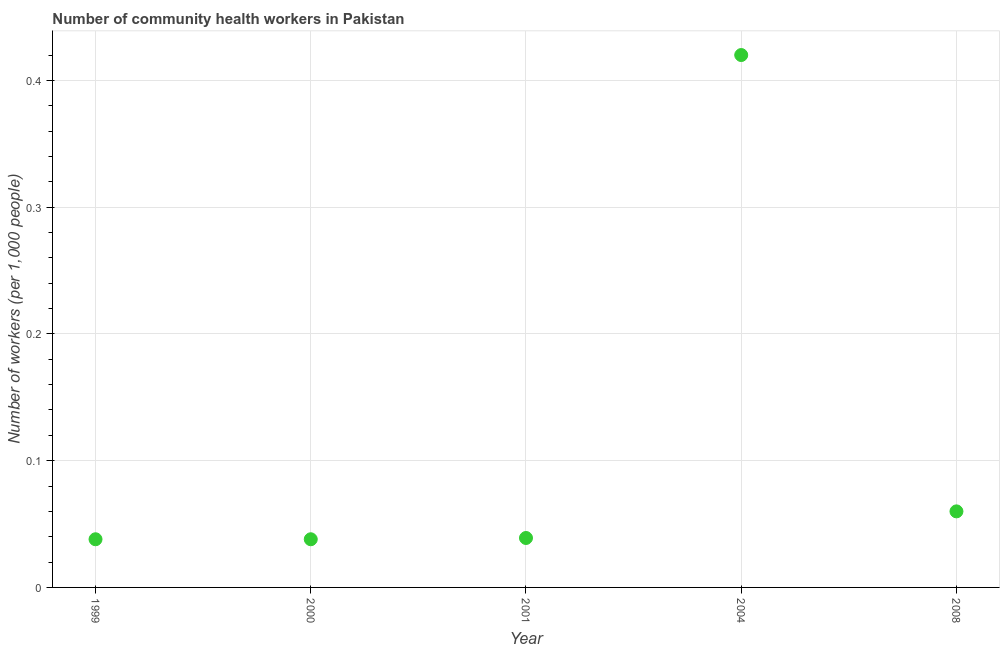What is the number of community health workers in 2004?
Offer a very short reply. 0.42. Across all years, what is the maximum number of community health workers?
Give a very brief answer. 0.42. Across all years, what is the minimum number of community health workers?
Your response must be concise. 0.04. What is the sum of the number of community health workers?
Make the answer very short. 0.59. What is the difference between the number of community health workers in 1999 and 2001?
Offer a very short reply. -0. What is the average number of community health workers per year?
Your response must be concise. 0.12. What is the median number of community health workers?
Offer a terse response. 0.04. In how many years, is the number of community health workers greater than 0.36000000000000004 ?
Your answer should be compact. 1. What is the ratio of the number of community health workers in 1999 to that in 2008?
Your response must be concise. 0.63. Is the number of community health workers in 1999 less than that in 2001?
Make the answer very short. Yes. Is the difference between the number of community health workers in 1999 and 2004 greater than the difference between any two years?
Your answer should be compact. Yes. What is the difference between the highest and the second highest number of community health workers?
Offer a terse response. 0.36. Is the sum of the number of community health workers in 2000 and 2001 greater than the maximum number of community health workers across all years?
Provide a short and direct response. No. What is the difference between the highest and the lowest number of community health workers?
Offer a terse response. 0.38. In how many years, is the number of community health workers greater than the average number of community health workers taken over all years?
Keep it short and to the point. 1. Does the number of community health workers monotonically increase over the years?
Provide a succinct answer. No. What is the difference between two consecutive major ticks on the Y-axis?
Offer a very short reply. 0.1. What is the title of the graph?
Keep it short and to the point. Number of community health workers in Pakistan. What is the label or title of the X-axis?
Your answer should be compact. Year. What is the label or title of the Y-axis?
Give a very brief answer. Number of workers (per 1,0 people). What is the Number of workers (per 1,000 people) in 1999?
Your answer should be compact. 0.04. What is the Number of workers (per 1,000 people) in 2000?
Provide a succinct answer. 0.04. What is the Number of workers (per 1,000 people) in 2001?
Ensure brevity in your answer.  0.04. What is the Number of workers (per 1,000 people) in 2004?
Your response must be concise. 0.42. What is the Number of workers (per 1,000 people) in 2008?
Offer a terse response. 0.06. What is the difference between the Number of workers (per 1,000 people) in 1999 and 2000?
Give a very brief answer. 0. What is the difference between the Number of workers (per 1,000 people) in 1999 and 2001?
Offer a very short reply. -0. What is the difference between the Number of workers (per 1,000 people) in 1999 and 2004?
Make the answer very short. -0.38. What is the difference between the Number of workers (per 1,000 people) in 1999 and 2008?
Give a very brief answer. -0.02. What is the difference between the Number of workers (per 1,000 people) in 2000 and 2001?
Give a very brief answer. -0. What is the difference between the Number of workers (per 1,000 people) in 2000 and 2004?
Offer a terse response. -0.38. What is the difference between the Number of workers (per 1,000 people) in 2000 and 2008?
Your answer should be very brief. -0.02. What is the difference between the Number of workers (per 1,000 people) in 2001 and 2004?
Provide a succinct answer. -0.38. What is the difference between the Number of workers (per 1,000 people) in 2001 and 2008?
Offer a very short reply. -0.02. What is the difference between the Number of workers (per 1,000 people) in 2004 and 2008?
Ensure brevity in your answer.  0.36. What is the ratio of the Number of workers (per 1,000 people) in 1999 to that in 2001?
Ensure brevity in your answer.  0.97. What is the ratio of the Number of workers (per 1,000 people) in 1999 to that in 2004?
Provide a short and direct response. 0.09. What is the ratio of the Number of workers (per 1,000 people) in 1999 to that in 2008?
Ensure brevity in your answer.  0.63. What is the ratio of the Number of workers (per 1,000 people) in 2000 to that in 2004?
Ensure brevity in your answer.  0.09. What is the ratio of the Number of workers (per 1,000 people) in 2000 to that in 2008?
Your response must be concise. 0.63. What is the ratio of the Number of workers (per 1,000 people) in 2001 to that in 2004?
Ensure brevity in your answer.  0.09. What is the ratio of the Number of workers (per 1,000 people) in 2001 to that in 2008?
Provide a short and direct response. 0.65. What is the ratio of the Number of workers (per 1,000 people) in 2004 to that in 2008?
Give a very brief answer. 7. 